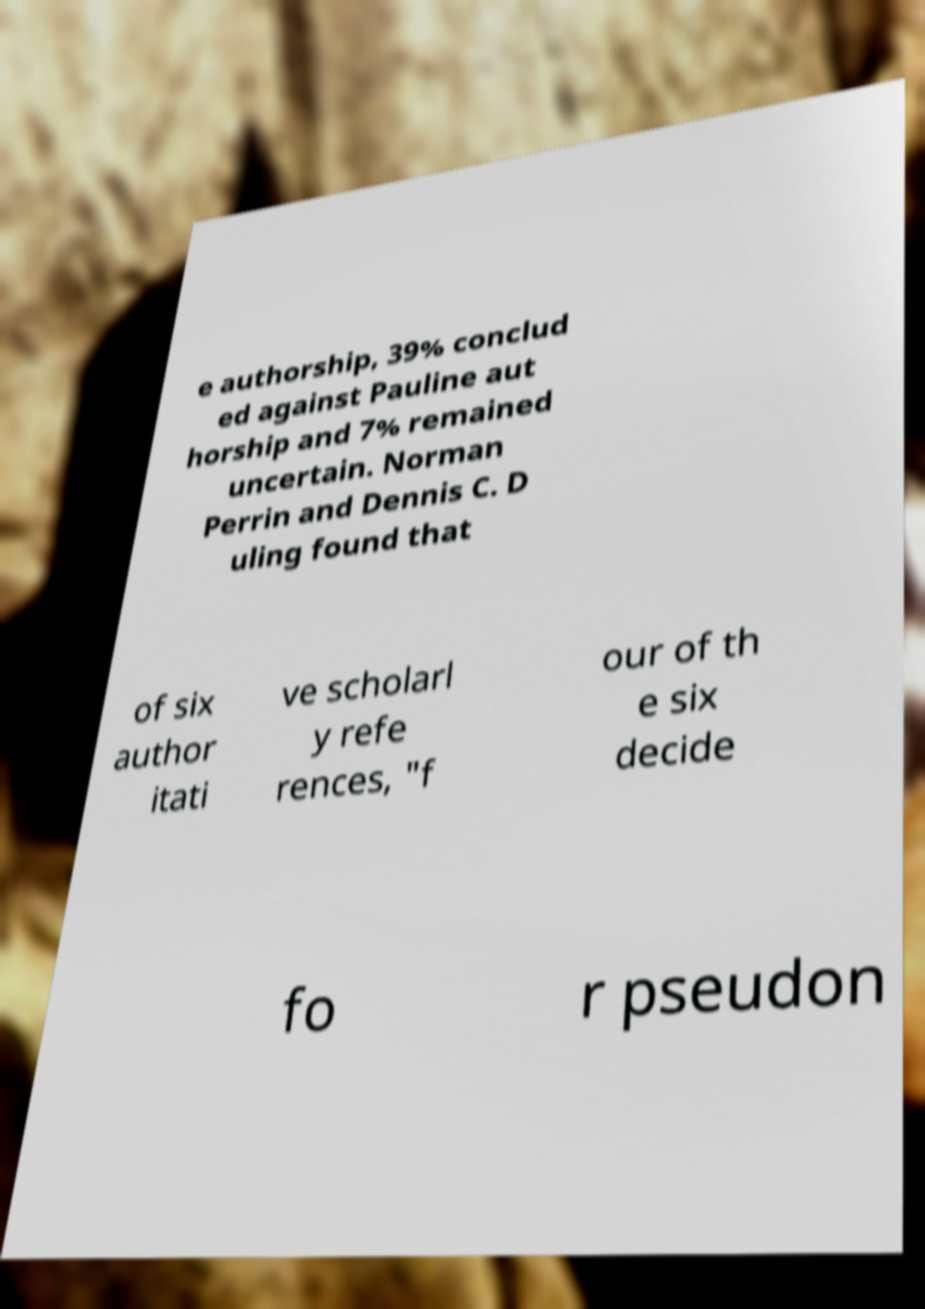Can you accurately transcribe the text from the provided image for me? e authorship, 39% conclud ed against Pauline aut horship and 7% remained uncertain. Norman Perrin and Dennis C. D uling found that of six author itati ve scholarl y refe rences, "f our of th e six decide fo r pseudon 